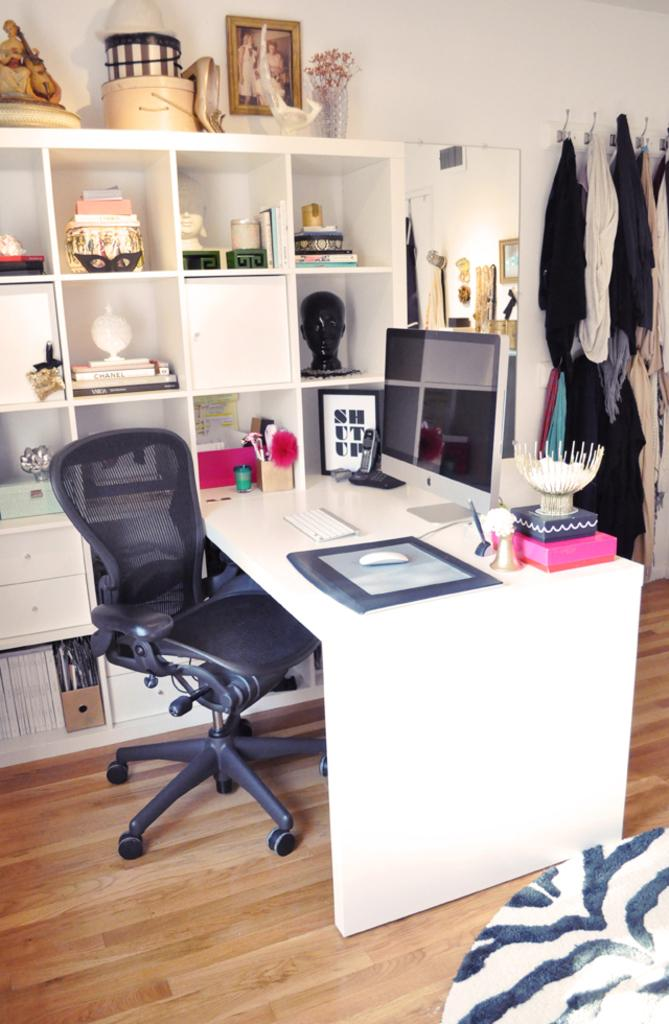<image>
Present a compact description of the photo's key features. A room with a framed out picture saying shut up 